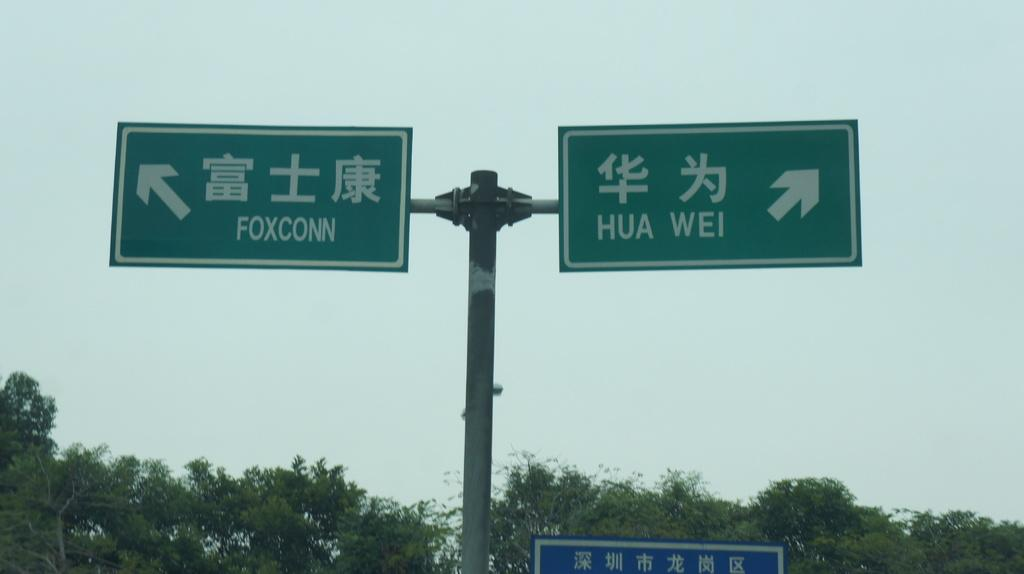<image>
Summarize the visual content of the image. Two green highway signs with one saying Hua Wei. 